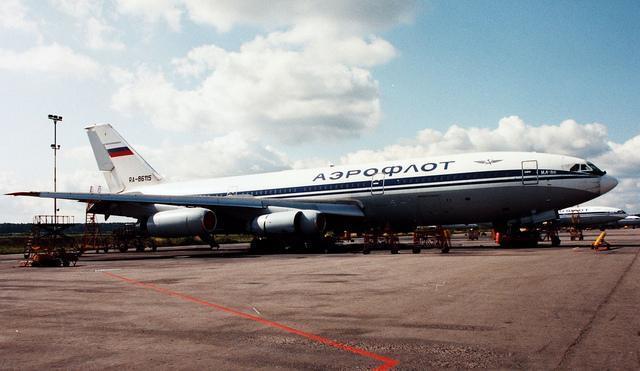How many engines on the plane?
Give a very brief answer. 4. 